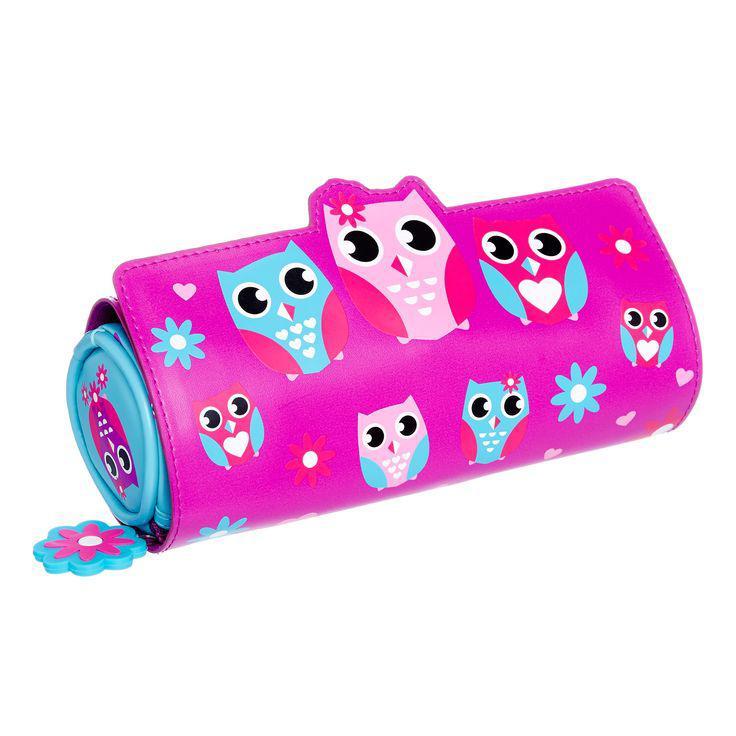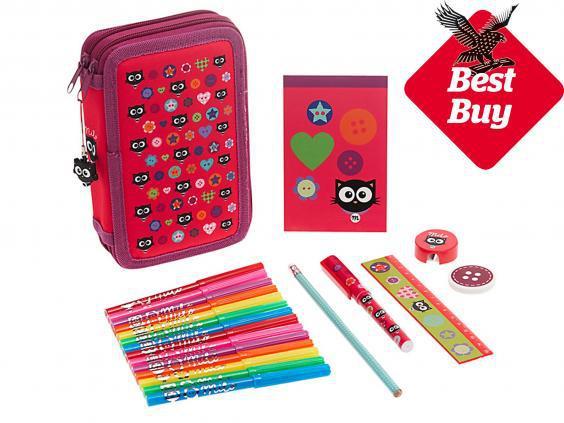The first image is the image on the left, the second image is the image on the right. For the images shown, is this caption "The left image shows just one cyindrical pencil case." true? Answer yes or no. Yes. 